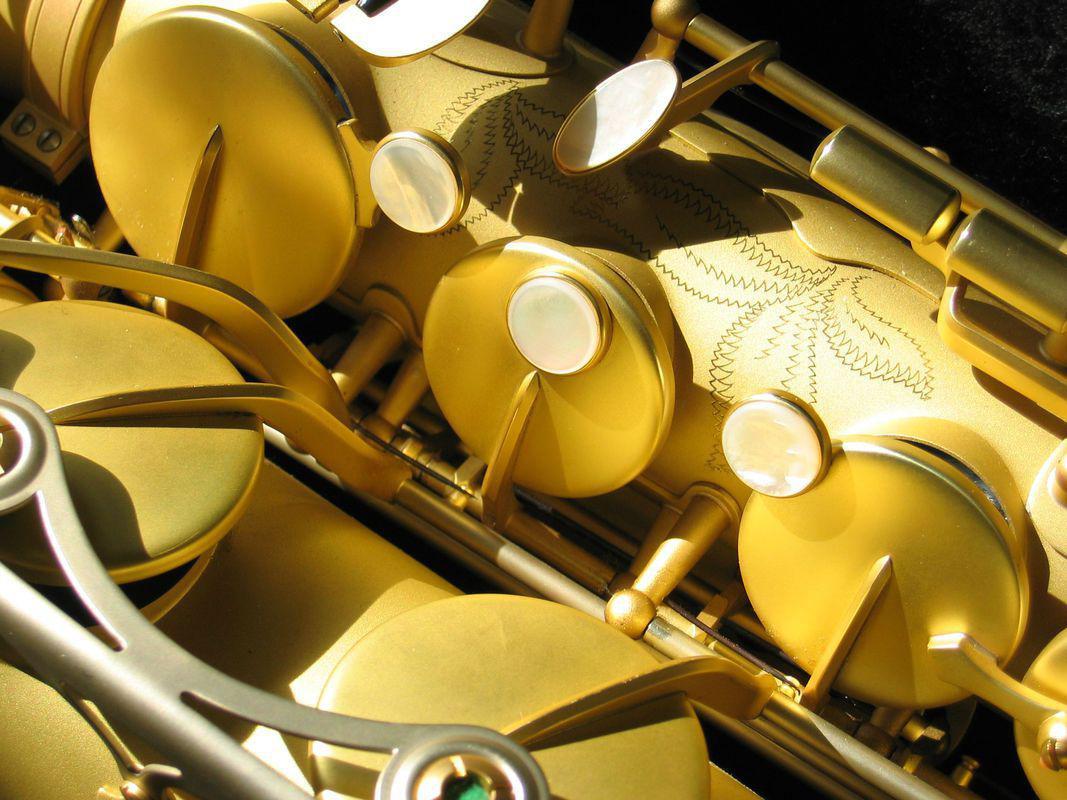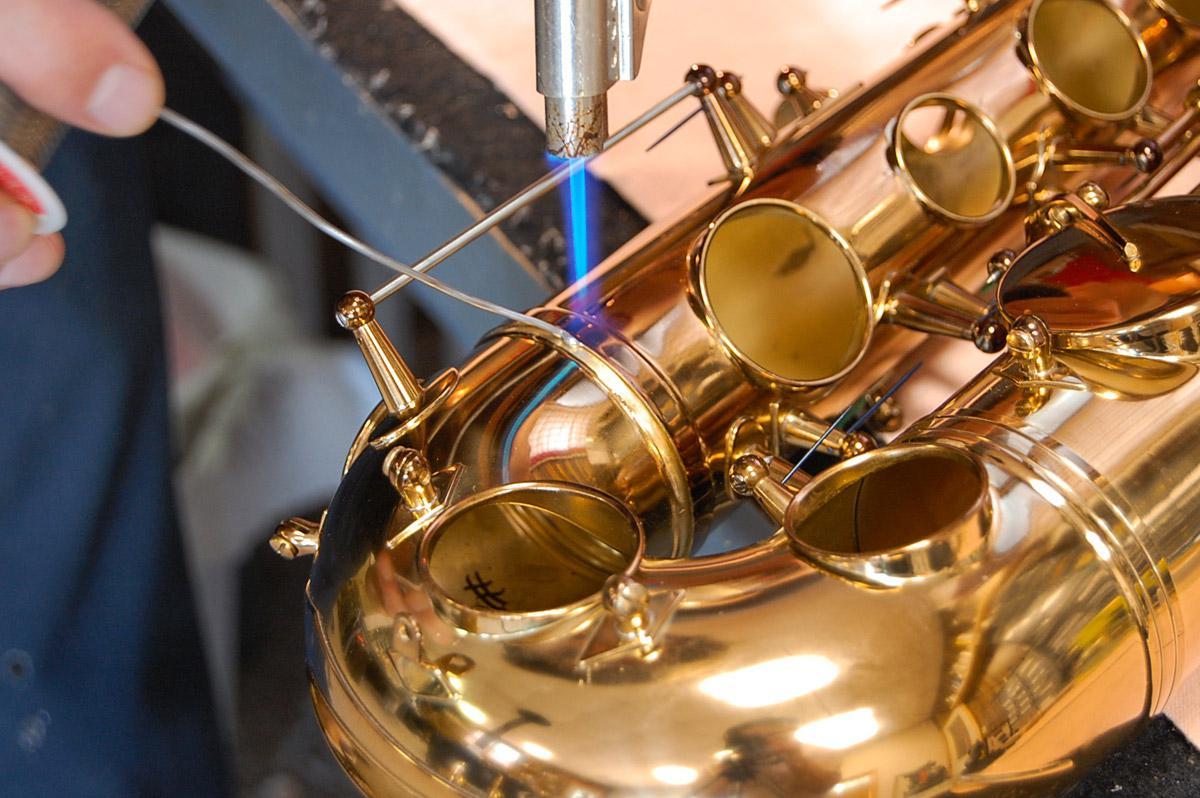The first image is the image on the left, the second image is the image on the right. For the images shown, is this caption "A section of a brass-colored instrument containing button and lever shapes is displayed on a white background." true? Answer yes or no. No. 